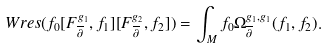Convert formula to latex. <formula><loc_0><loc_0><loc_500><loc_500>W r e s ( f _ { 0 } [ F ^ { g _ { 1 } } _ { \overline { \partial } } , f _ { 1 } ] [ F ^ { g _ { 2 } } _ { \overline { \partial } } , f _ { 2 } ] ) = \int _ { M } f _ { 0 } \Omega ^ { g _ { 1 } , g _ { 1 } } _ { \overline { \partial } } ( f _ { 1 } , f _ { 2 } ) .</formula> 